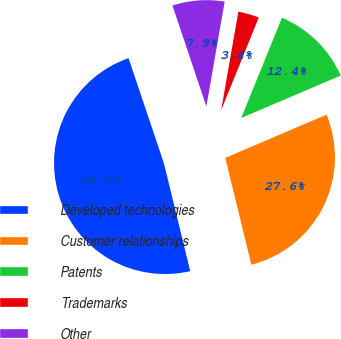Convert chart to OTSL. <chart><loc_0><loc_0><loc_500><loc_500><pie_chart><fcel>Developed technologies<fcel>Customer relationships<fcel>Patents<fcel>Trademarks<fcel>Other<nl><fcel>48.64%<fcel>27.61%<fcel>12.44%<fcel>3.39%<fcel>7.92%<nl></chart> 